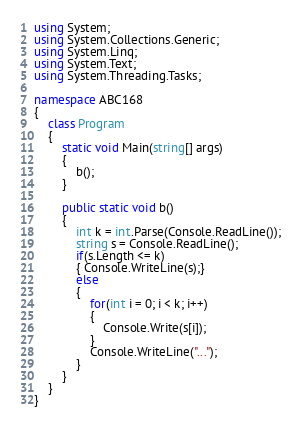<code> <loc_0><loc_0><loc_500><loc_500><_C#_>using System;
using System.Collections.Generic;
using System.Linq;
using System.Text;
using System.Threading.Tasks;

namespace ABC168
{
    class Program
    {
        static void Main(string[] args)
        {
            b();
        }

        public static void b()
        {
            int k = int.Parse(Console.ReadLine());
            string s = Console.ReadLine();
            if(s.Length <= k)
            { Console.WriteLine(s);}
            else
            {
                for(int i = 0; i < k; i++)
                {
                    Console.Write(s[i]);
                }
                Console.WriteLine("...");
            }
        }
    }
}
</code> 